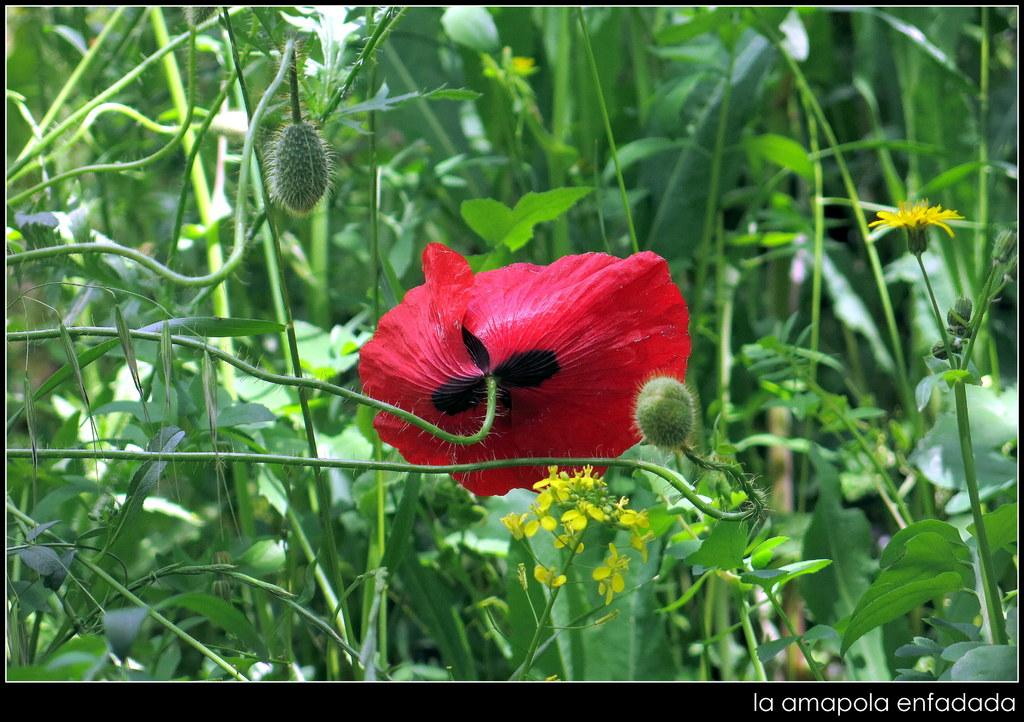What type of flora can be seen in the image? There are flowers and buds in the image. Can you describe the plants in the background of the image? The plants in the background of the image are not specified, but they are present. What type of fruit is being kicked in the image? There is no fruit or kicking activity present in the image. 